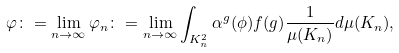Convert formula to latex. <formula><loc_0><loc_0><loc_500><loc_500>\varphi \colon = \lim _ { n \rightarrow \infty } \varphi _ { n } \colon = \lim _ { n \rightarrow \infty } \int _ { K _ { n } ^ { 2 } } \alpha ^ { g } ( \phi ) f ( g ) \frac { 1 } { \mu ( K _ { n } ) } d \mu ( K _ { n } ) ,</formula> 